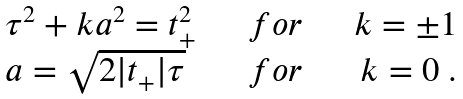<formula> <loc_0><loc_0><loc_500><loc_500>\begin{array} { l c r } { { \tau ^ { 2 } + k a ^ { 2 } = t _ { + } ^ { 2 } } } & { \quad f o r \quad } & { k = \pm 1 } \\ { { a = \sqrt { 2 | t _ { + } | \tau } } } & { \quad f o r \quad } & { k = 0 \ . } \end{array}</formula> 